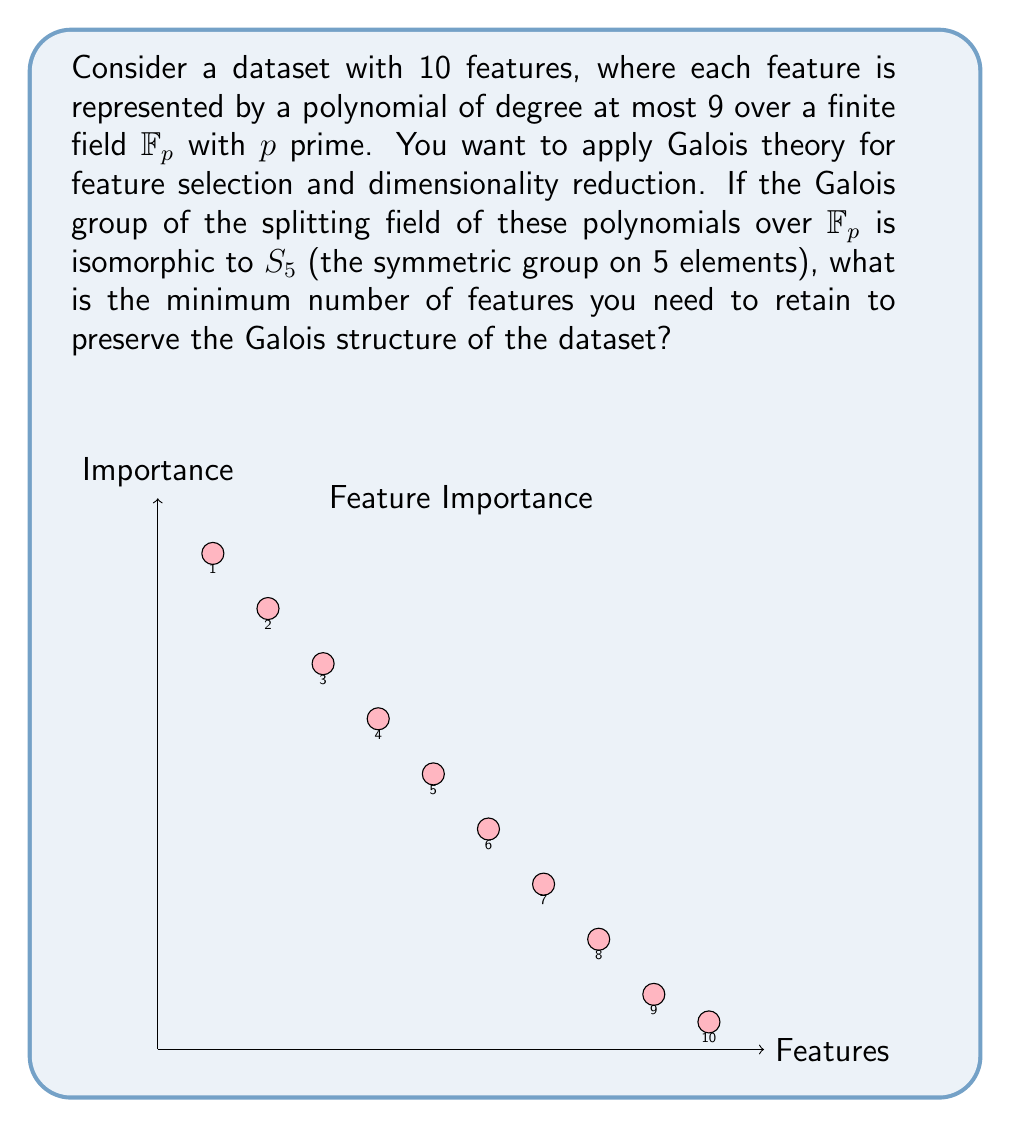Give your solution to this math problem. Let's approach this step-by-step:

1) First, recall that in Galois theory, the Galois group of a polynomial represents the symmetries of its roots. The order of the Galois group is equal to the degree of the splitting field extension.

2) We're given that the Galois group is isomorphic to $S_5$. The order of $S_5$ is $5! = 120$.

3) This means that the splitting field of our polynomials has degree 120 over $\mathbb{F}_p$.

4) In the context of feature selection, each feature (polynomial) contributes to this Galois structure. We want to preserve this structure while reducing dimensionality.

5) The fundamental theorem of Galois theory establishes a one-to-one correspondence between subfields of the splitting field and subgroups of the Galois group.

6) $S_5$ has a chain of subgroups:
   $\{e\} \subset S_2 \subset S_3 \subset S_4 \subset S_5$

7) The longest chain of subgroups has length 5, which corresponds to the number of features we need to retain to preserve the full Galois structure.

8) Intuitively, each feature we retain allows us to "climb" one step in this subgroup chain, until we reach the full group $S_5$.

9) Therefore, we need to retain at least 5 features to preserve the Galois structure of the dataset.
Answer: 5 features 